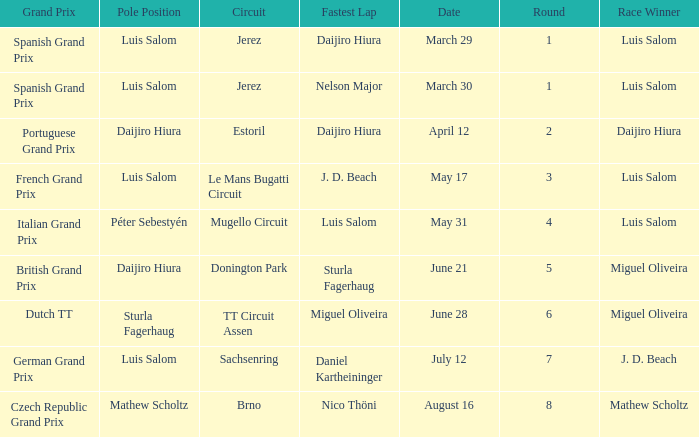What grand prixs did Daijiro Hiura win?  Portuguese Grand Prix. 